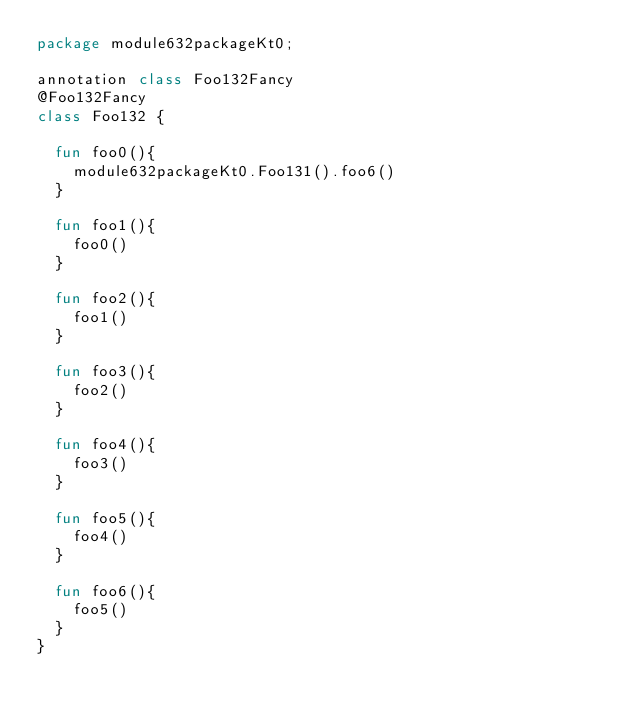Convert code to text. <code><loc_0><loc_0><loc_500><loc_500><_Kotlin_>package module632packageKt0;

annotation class Foo132Fancy
@Foo132Fancy
class Foo132 {

  fun foo0(){
    module632packageKt0.Foo131().foo6()
  }

  fun foo1(){
    foo0()
  }

  fun foo2(){
    foo1()
  }

  fun foo3(){
    foo2()
  }

  fun foo4(){
    foo3()
  }

  fun foo5(){
    foo4()
  }

  fun foo6(){
    foo5()
  }
}</code> 